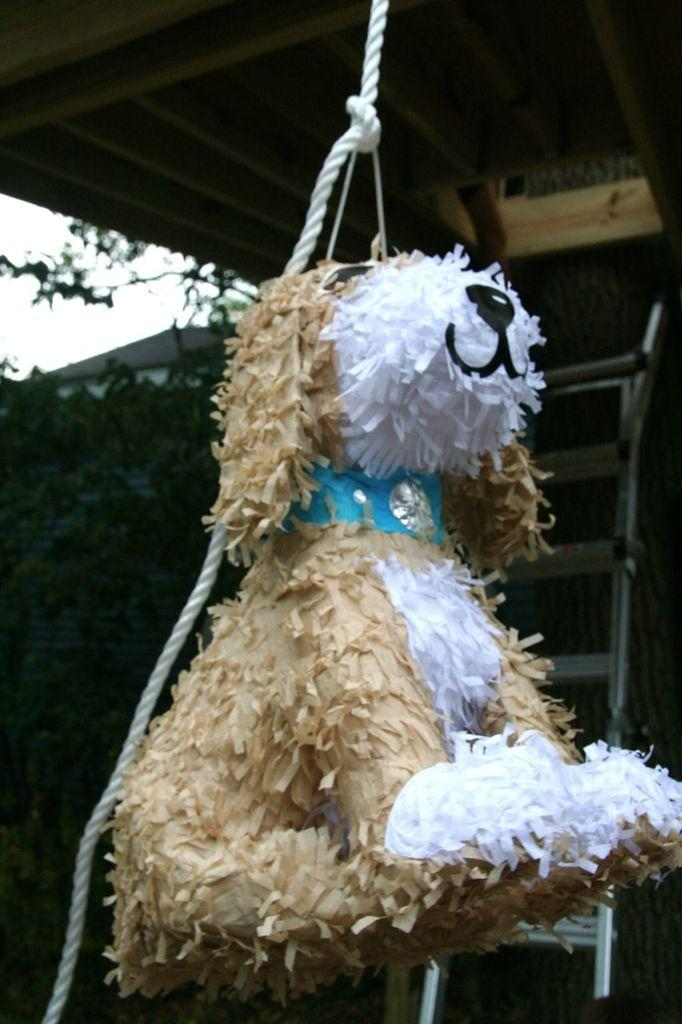What is the main object in the foreground of the picture? There is a toy in the foreground of the picture. How is the toy positioned in relation to the shed? The toy is hanging on the roof of the shed. How is the toy attached to the roof? The toy is attached to the roof with a rope. What can be seen in the background of the image? There is sky, trees, and a ladder visible in the background of the image. What type of pan is being used to cook on the roof of the shed? There is no pan or cooking activity present in the image; it features a toy hanging on the roof of a shed. How much does the screw holding the toy to the roof weigh? There is no screw mentioned in the image; the toy is attached to the roof with a rope. 